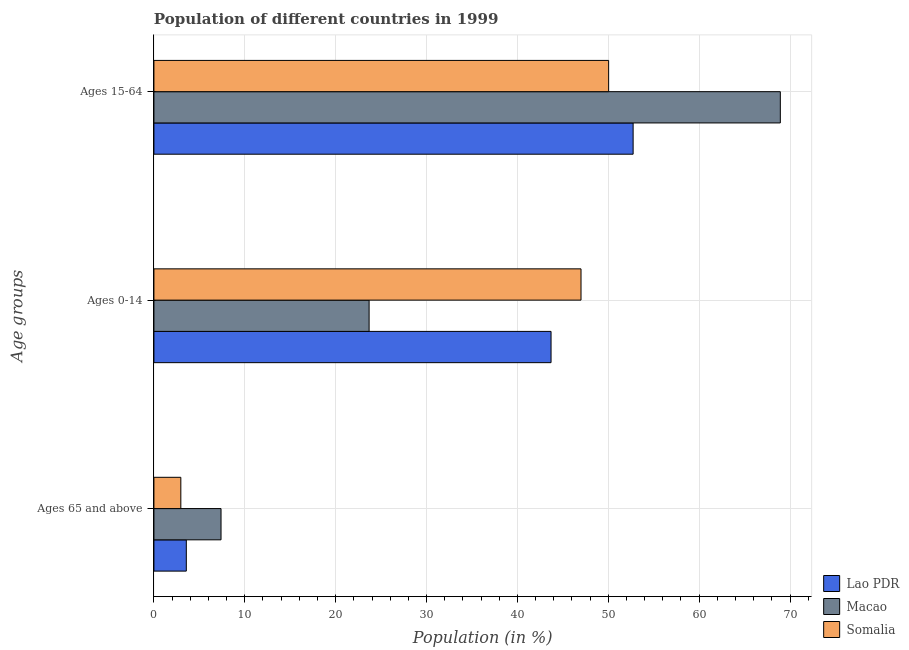How many different coloured bars are there?
Your response must be concise. 3. Are the number of bars on each tick of the Y-axis equal?
Offer a terse response. Yes. What is the label of the 2nd group of bars from the top?
Your response must be concise. Ages 0-14. What is the percentage of population within the age-group 15-64 in Somalia?
Give a very brief answer. 50.04. Across all countries, what is the maximum percentage of population within the age-group of 65 and above?
Make the answer very short. 7.39. Across all countries, what is the minimum percentage of population within the age-group of 65 and above?
Offer a very short reply. 2.96. In which country was the percentage of population within the age-group 0-14 maximum?
Make the answer very short. Somalia. In which country was the percentage of population within the age-group 0-14 minimum?
Ensure brevity in your answer.  Macao. What is the total percentage of population within the age-group 0-14 in the graph?
Provide a succinct answer. 114.38. What is the difference between the percentage of population within the age-group of 65 and above in Lao PDR and that in Macao?
Your answer should be compact. -3.82. What is the difference between the percentage of population within the age-group 0-14 in Macao and the percentage of population within the age-group of 65 and above in Somalia?
Your answer should be very brief. 20.72. What is the average percentage of population within the age-group 0-14 per country?
Your answer should be very brief. 38.13. What is the difference between the percentage of population within the age-group of 65 and above and percentage of population within the age-group 15-64 in Somalia?
Keep it short and to the point. -47.08. In how many countries, is the percentage of population within the age-group of 65 and above greater than 8 %?
Give a very brief answer. 0. What is the ratio of the percentage of population within the age-group 15-64 in Somalia to that in Macao?
Offer a very short reply. 0.73. Is the percentage of population within the age-group 0-14 in Macao less than that in Lao PDR?
Your answer should be very brief. Yes. Is the difference between the percentage of population within the age-group of 65 and above in Somalia and Macao greater than the difference between the percentage of population within the age-group 15-64 in Somalia and Macao?
Your answer should be compact. Yes. What is the difference between the highest and the second highest percentage of population within the age-group of 65 and above?
Give a very brief answer. 3.82. What is the difference between the highest and the lowest percentage of population within the age-group 0-14?
Ensure brevity in your answer.  23.32. In how many countries, is the percentage of population within the age-group of 65 and above greater than the average percentage of population within the age-group of 65 and above taken over all countries?
Give a very brief answer. 1. What does the 1st bar from the top in Ages 0-14 represents?
Ensure brevity in your answer.  Somalia. What does the 1st bar from the bottom in Ages 15-64 represents?
Your response must be concise. Lao PDR. Is it the case that in every country, the sum of the percentage of population within the age-group of 65 and above and percentage of population within the age-group 0-14 is greater than the percentage of population within the age-group 15-64?
Your answer should be compact. No. How many bars are there?
Give a very brief answer. 9. What is the difference between two consecutive major ticks on the X-axis?
Your response must be concise. 10. Does the graph contain any zero values?
Ensure brevity in your answer.  No. Where does the legend appear in the graph?
Keep it short and to the point. Bottom right. How are the legend labels stacked?
Provide a short and direct response. Vertical. What is the title of the graph?
Provide a succinct answer. Population of different countries in 1999. Does "High income: OECD" appear as one of the legend labels in the graph?
Keep it short and to the point. No. What is the label or title of the Y-axis?
Your response must be concise. Age groups. What is the Population (in %) of Lao PDR in Ages 65 and above?
Make the answer very short. 3.56. What is the Population (in %) in Macao in Ages 65 and above?
Give a very brief answer. 7.39. What is the Population (in %) of Somalia in Ages 65 and above?
Your response must be concise. 2.96. What is the Population (in %) in Lao PDR in Ages 0-14?
Your answer should be very brief. 43.7. What is the Population (in %) of Macao in Ages 0-14?
Provide a succinct answer. 23.68. What is the Population (in %) of Somalia in Ages 0-14?
Give a very brief answer. 47. What is the Population (in %) in Lao PDR in Ages 15-64?
Provide a short and direct response. 52.73. What is the Population (in %) in Macao in Ages 15-64?
Provide a succinct answer. 68.93. What is the Population (in %) in Somalia in Ages 15-64?
Your answer should be very brief. 50.04. Across all Age groups, what is the maximum Population (in %) in Lao PDR?
Your answer should be very brief. 52.73. Across all Age groups, what is the maximum Population (in %) of Macao?
Provide a succinct answer. 68.93. Across all Age groups, what is the maximum Population (in %) of Somalia?
Keep it short and to the point. 50.04. Across all Age groups, what is the minimum Population (in %) in Lao PDR?
Provide a short and direct response. 3.56. Across all Age groups, what is the minimum Population (in %) of Macao?
Your answer should be compact. 7.39. Across all Age groups, what is the minimum Population (in %) of Somalia?
Give a very brief answer. 2.96. What is the total Population (in %) in Macao in the graph?
Give a very brief answer. 100. What is the total Population (in %) in Somalia in the graph?
Keep it short and to the point. 100. What is the difference between the Population (in %) in Lao PDR in Ages 65 and above and that in Ages 0-14?
Your answer should be very brief. -40.14. What is the difference between the Population (in %) of Macao in Ages 65 and above and that in Ages 0-14?
Make the answer very short. -16.3. What is the difference between the Population (in %) of Somalia in Ages 65 and above and that in Ages 0-14?
Offer a terse response. -44.04. What is the difference between the Population (in %) of Lao PDR in Ages 65 and above and that in Ages 15-64?
Make the answer very short. -49.17. What is the difference between the Population (in %) in Macao in Ages 65 and above and that in Ages 15-64?
Provide a succinct answer. -61.55. What is the difference between the Population (in %) in Somalia in Ages 65 and above and that in Ages 15-64?
Your answer should be very brief. -47.08. What is the difference between the Population (in %) in Lao PDR in Ages 0-14 and that in Ages 15-64?
Provide a short and direct response. -9.03. What is the difference between the Population (in %) in Macao in Ages 0-14 and that in Ages 15-64?
Your response must be concise. -45.25. What is the difference between the Population (in %) in Somalia in Ages 0-14 and that in Ages 15-64?
Provide a succinct answer. -3.04. What is the difference between the Population (in %) in Lao PDR in Ages 65 and above and the Population (in %) in Macao in Ages 0-14?
Your response must be concise. -20.12. What is the difference between the Population (in %) in Lao PDR in Ages 65 and above and the Population (in %) in Somalia in Ages 0-14?
Ensure brevity in your answer.  -43.44. What is the difference between the Population (in %) of Macao in Ages 65 and above and the Population (in %) of Somalia in Ages 0-14?
Offer a very short reply. -39.61. What is the difference between the Population (in %) of Lao PDR in Ages 65 and above and the Population (in %) of Macao in Ages 15-64?
Your answer should be very brief. -65.37. What is the difference between the Population (in %) of Lao PDR in Ages 65 and above and the Population (in %) of Somalia in Ages 15-64?
Make the answer very short. -46.48. What is the difference between the Population (in %) of Macao in Ages 65 and above and the Population (in %) of Somalia in Ages 15-64?
Offer a terse response. -42.65. What is the difference between the Population (in %) in Lao PDR in Ages 0-14 and the Population (in %) in Macao in Ages 15-64?
Your response must be concise. -25.23. What is the difference between the Population (in %) in Lao PDR in Ages 0-14 and the Population (in %) in Somalia in Ages 15-64?
Your answer should be very brief. -6.34. What is the difference between the Population (in %) of Macao in Ages 0-14 and the Population (in %) of Somalia in Ages 15-64?
Give a very brief answer. -26.36. What is the average Population (in %) in Lao PDR per Age groups?
Provide a succinct answer. 33.33. What is the average Population (in %) in Macao per Age groups?
Offer a terse response. 33.33. What is the average Population (in %) in Somalia per Age groups?
Your answer should be compact. 33.33. What is the difference between the Population (in %) in Lao PDR and Population (in %) in Macao in Ages 65 and above?
Ensure brevity in your answer.  -3.82. What is the difference between the Population (in %) in Lao PDR and Population (in %) in Somalia in Ages 65 and above?
Your response must be concise. 0.6. What is the difference between the Population (in %) in Macao and Population (in %) in Somalia in Ages 65 and above?
Offer a very short reply. 4.42. What is the difference between the Population (in %) in Lao PDR and Population (in %) in Macao in Ages 0-14?
Provide a short and direct response. 20.02. What is the difference between the Population (in %) in Lao PDR and Population (in %) in Somalia in Ages 0-14?
Make the answer very short. -3.3. What is the difference between the Population (in %) in Macao and Population (in %) in Somalia in Ages 0-14?
Your answer should be compact. -23.32. What is the difference between the Population (in %) of Lao PDR and Population (in %) of Macao in Ages 15-64?
Provide a short and direct response. -16.2. What is the difference between the Population (in %) of Lao PDR and Population (in %) of Somalia in Ages 15-64?
Your response must be concise. 2.69. What is the difference between the Population (in %) in Macao and Population (in %) in Somalia in Ages 15-64?
Provide a succinct answer. 18.89. What is the ratio of the Population (in %) of Lao PDR in Ages 65 and above to that in Ages 0-14?
Make the answer very short. 0.08. What is the ratio of the Population (in %) in Macao in Ages 65 and above to that in Ages 0-14?
Provide a short and direct response. 0.31. What is the ratio of the Population (in %) in Somalia in Ages 65 and above to that in Ages 0-14?
Keep it short and to the point. 0.06. What is the ratio of the Population (in %) in Lao PDR in Ages 65 and above to that in Ages 15-64?
Your response must be concise. 0.07. What is the ratio of the Population (in %) in Macao in Ages 65 and above to that in Ages 15-64?
Your answer should be compact. 0.11. What is the ratio of the Population (in %) in Somalia in Ages 65 and above to that in Ages 15-64?
Your response must be concise. 0.06. What is the ratio of the Population (in %) of Lao PDR in Ages 0-14 to that in Ages 15-64?
Your response must be concise. 0.83. What is the ratio of the Population (in %) in Macao in Ages 0-14 to that in Ages 15-64?
Provide a succinct answer. 0.34. What is the ratio of the Population (in %) in Somalia in Ages 0-14 to that in Ages 15-64?
Provide a succinct answer. 0.94. What is the difference between the highest and the second highest Population (in %) in Lao PDR?
Provide a succinct answer. 9.03. What is the difference between the highest and the second highest Population (in %) in Macao?
Your response must be concise. 45.25. What is the difference between the highest and the second highest Population (in %) in Somalia?
Ensure brevity in your answer.  3.04. What is the difference between the highest and the lowest Population (in %) in Lao PDR?
Offer a very short reply. 49.17. What is the difference between the highest and the lowest Population (in %) in Macao?
Your answer should be compact. 61.55. What is the difference between the highest and the lowest Population (in %) in Somalia?
Make the answer very short. 47.08. 